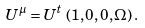<formula> <loc_0><loc_0><loc_500><loc_500>U ^ { \mu } = U ^ { t } \, \left ( 1 , 0 , 0 , \Omega \right ) .</formula> 